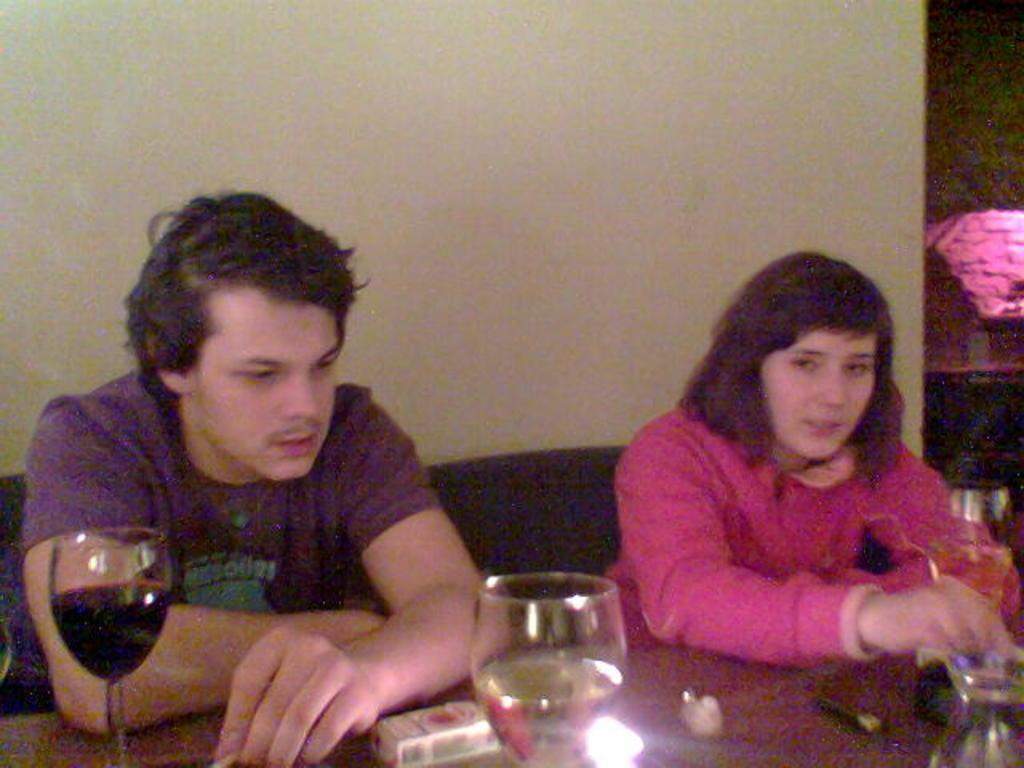Who is present in the image? There is a man and a woman in the image. What are the man and woman doing in the image? Both the man and woman are sitting in chairs. What can be seen on the table in the image? Wine glasses are placed on the table. What is visible in the background of the image? There is a wall in the background of the image. What type of wheel can be seen in the image? There is no wheel present in the image. What interests do the man and woman share, as depicted in the image? The image does not provide information about the interests of the man and woman. 